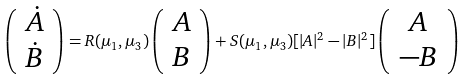<formula> <loc_0><loc_0><loc_500><loc_500>\left ( \begin{array} { c } \dot { A } \\ \dot { B } \end{array} \right ) = R ( \mu _ { 1 } , \mu _ { 3 } ) \left ( \begin{array} { c } { A } \\ { B } \end{array} \right ) + S ( \mu _ { 1 } , \mu _ { 3 } ) [ | A | ^ { 2 } - | B | ^ { 2 } ] \left ( \begin{array} { c } { A } \\ { - B } \end{array} \right )</formula> 